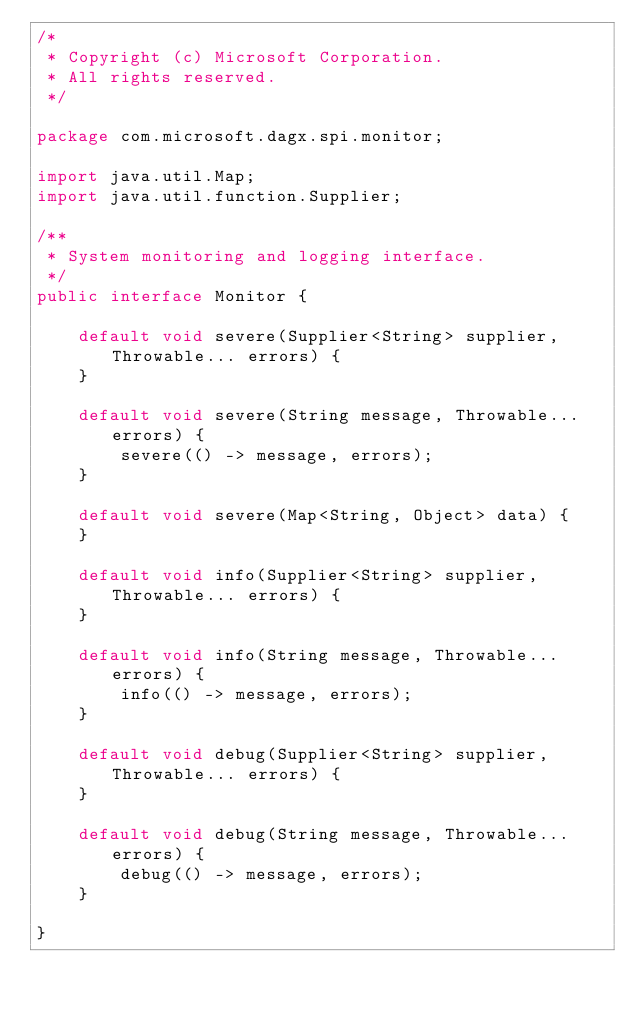Convert code to text. <code><loc_0><loc_0><loc_500><loc_500><_Java_>/*
 * Copyright (c) Microsoft Corporation.
 * All rights reserved.
 */

package com.microsoft.dagx.spi.monitor;

import java.util.Map;
import java.util.function.Supplier;

/**
 * System monitoring and logging interface.
 */
public interface Monitor {

    default void severe(Supplier<String> supplier, Throwable... errors) {
    }

    default void severe(String message, Throwable... errors) {
        severe(() -> message, errors);
    }

    default void severe(Map<String, Object> data) {
    }

    default void info(Supplier<String> supplier, Throwable... errors) {
    }

    default void info(String message, Throwable... errors) {
        info(() -> message, errors);
    }

    default void debug(Supplier<String> supplier, Throwable... errors) {
    }

    default void debug(String message, Throwable... errors) {
        debug(() -> message, errors);
    }

}
</code> 